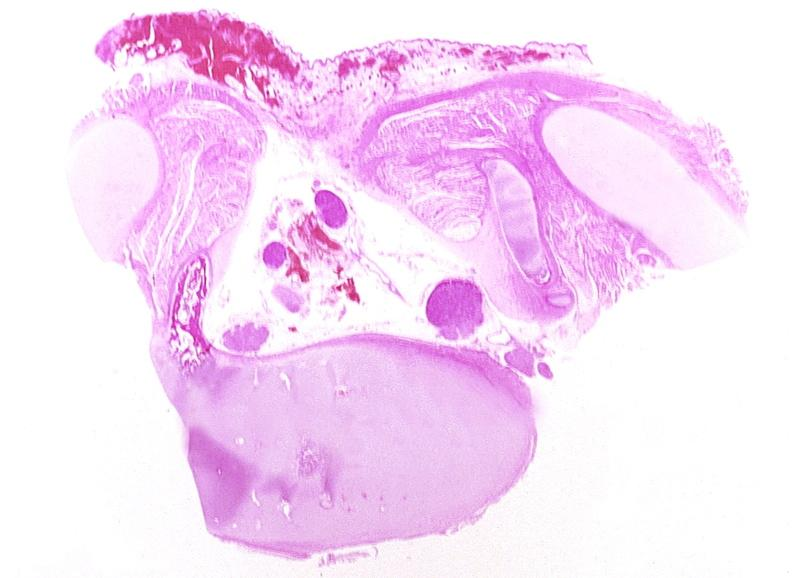s lupus erythematosus periarterial fibrosis present?
Answer the question using a single word or phrase. No 